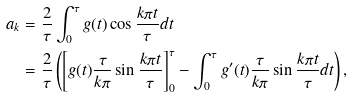Convert formula to latex. <formula><loc_0><loc_0><loc_500><loc_500>a _ { k } & = \frac { 2 } { \tau } \int _ { 0 } ^ { \tau } g ( t ) \cos \frac { k \pi t } { \tau } d t \\ & = \frac { 2 } { \tau } \left ( \left [ g ( t ) \frac { \tau } { k \pi } \sin \frac { k \pi t } { \tau } \right ] _ { 0 } ^ { \tau } - \int _ { 0 } ^ { \tau } g ^ { \prime } ( t ) \frac { \tau } { k \pi } \sin \frac { k \pi t } { \tau } d t \right ) ,</formula> 